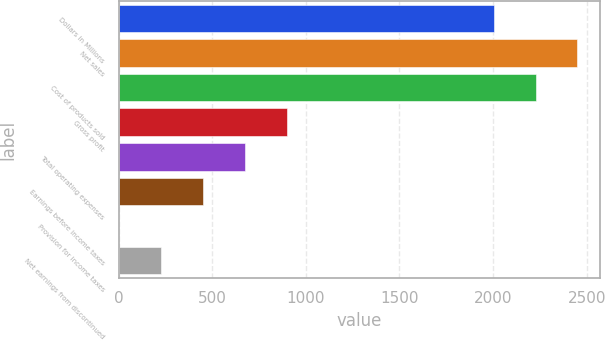Convert chart. <chart><loc_0><loc_0><loc_500><loc_500><bar_chart><fcel>Dollars in Millions<fcel>Net sales<fcel>Cost of products sold<fcel>Gross profit<fcel>Total operating expenses<fcel>Earnings before income taxes<fcel>Provision for income taxes<fcel>Net earnings from discontinued<nl><fcel>2003<fcel>2450.2<fcel>2226.6<fcel>899.4<fcel>675.8<fcel>452.2<fcel>5<fcel>228.6<nl></chart> 